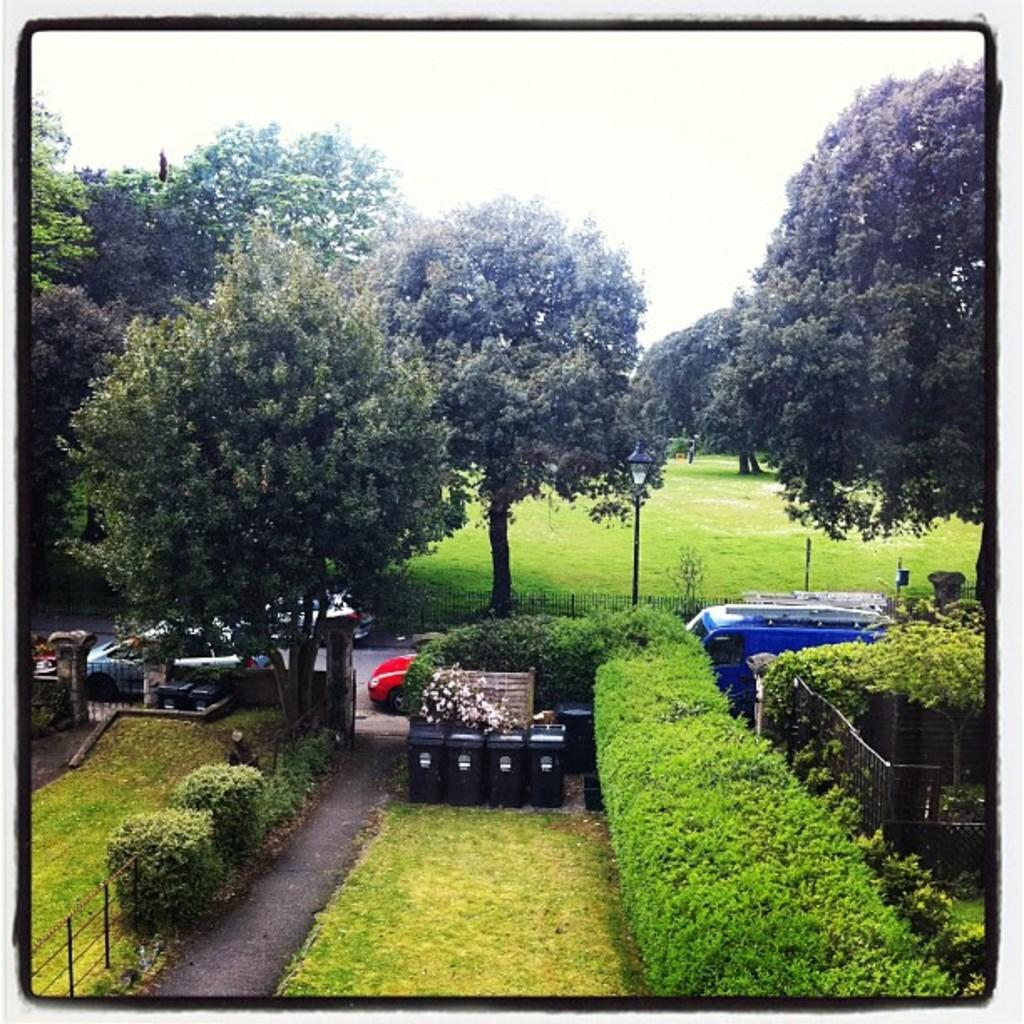What type of vegetation can be seen in the image? There is grass and plants in the image. What structures are present in the image? There are fences, bins, and a light pole in the image. What is happening on the road in the image? There are vehicles on the road in the image. What else can be seen in the image? There are trees in the image. What is visible in the background of the image? The sky is visible in the background of the image. What type of insurance is required for the bike in the image? There is no bike present in the image, so the question of insurance is not applicable. What knowledge can be gained from the image about the history of the area? The image does not provide any information about the history of the area, so it cannot be used to gain knowledge about the past. 